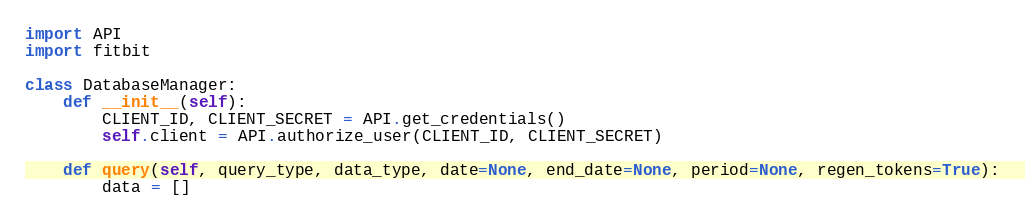Convert code to text. <code><loc_0><loc_0><loc_500><loc_500><_Python_>import API
import fitbit

class DatabaseManager:
    def __init__(self):
        CLIENT_ID, CLIENT_SECRET = API.get_credentials()
        self.client = API.authorize_user(CLIENT_ID, CLIENT_SECRET)

    def query(self, query_type, data_type, date=None, end_date=None, period=None, regen_tokens=True):
        data = []</code> 